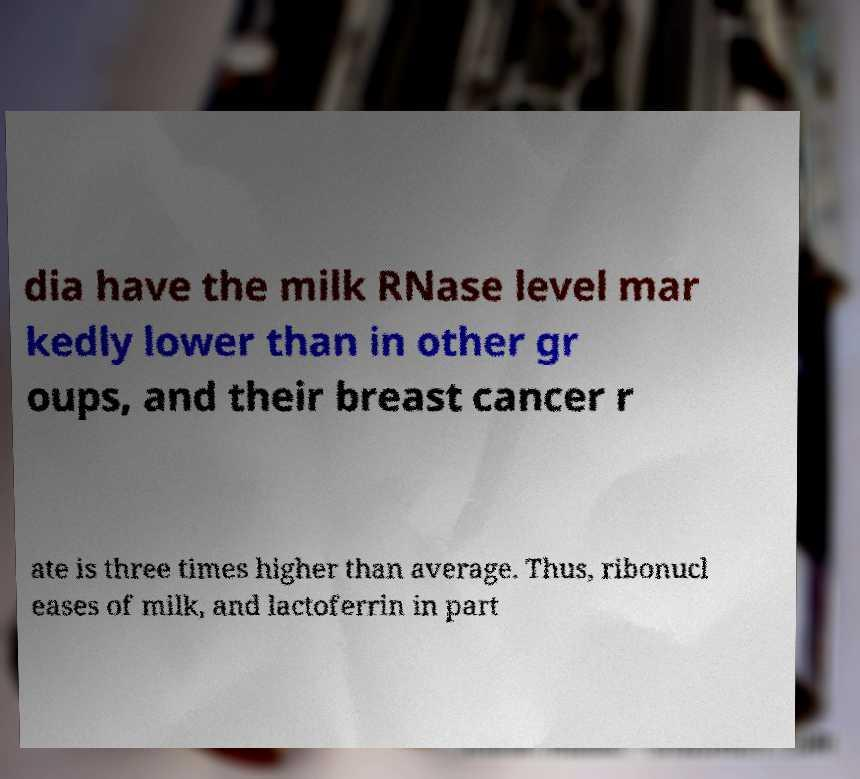Please read and relay the text visible in this image. What does it say? dia have the milk RNase level mar kedly lower than in other gr oups, and their breast cancer r ate is three times higher than average. Thus, ribonucl eases of milk, and lactoferrin in part 